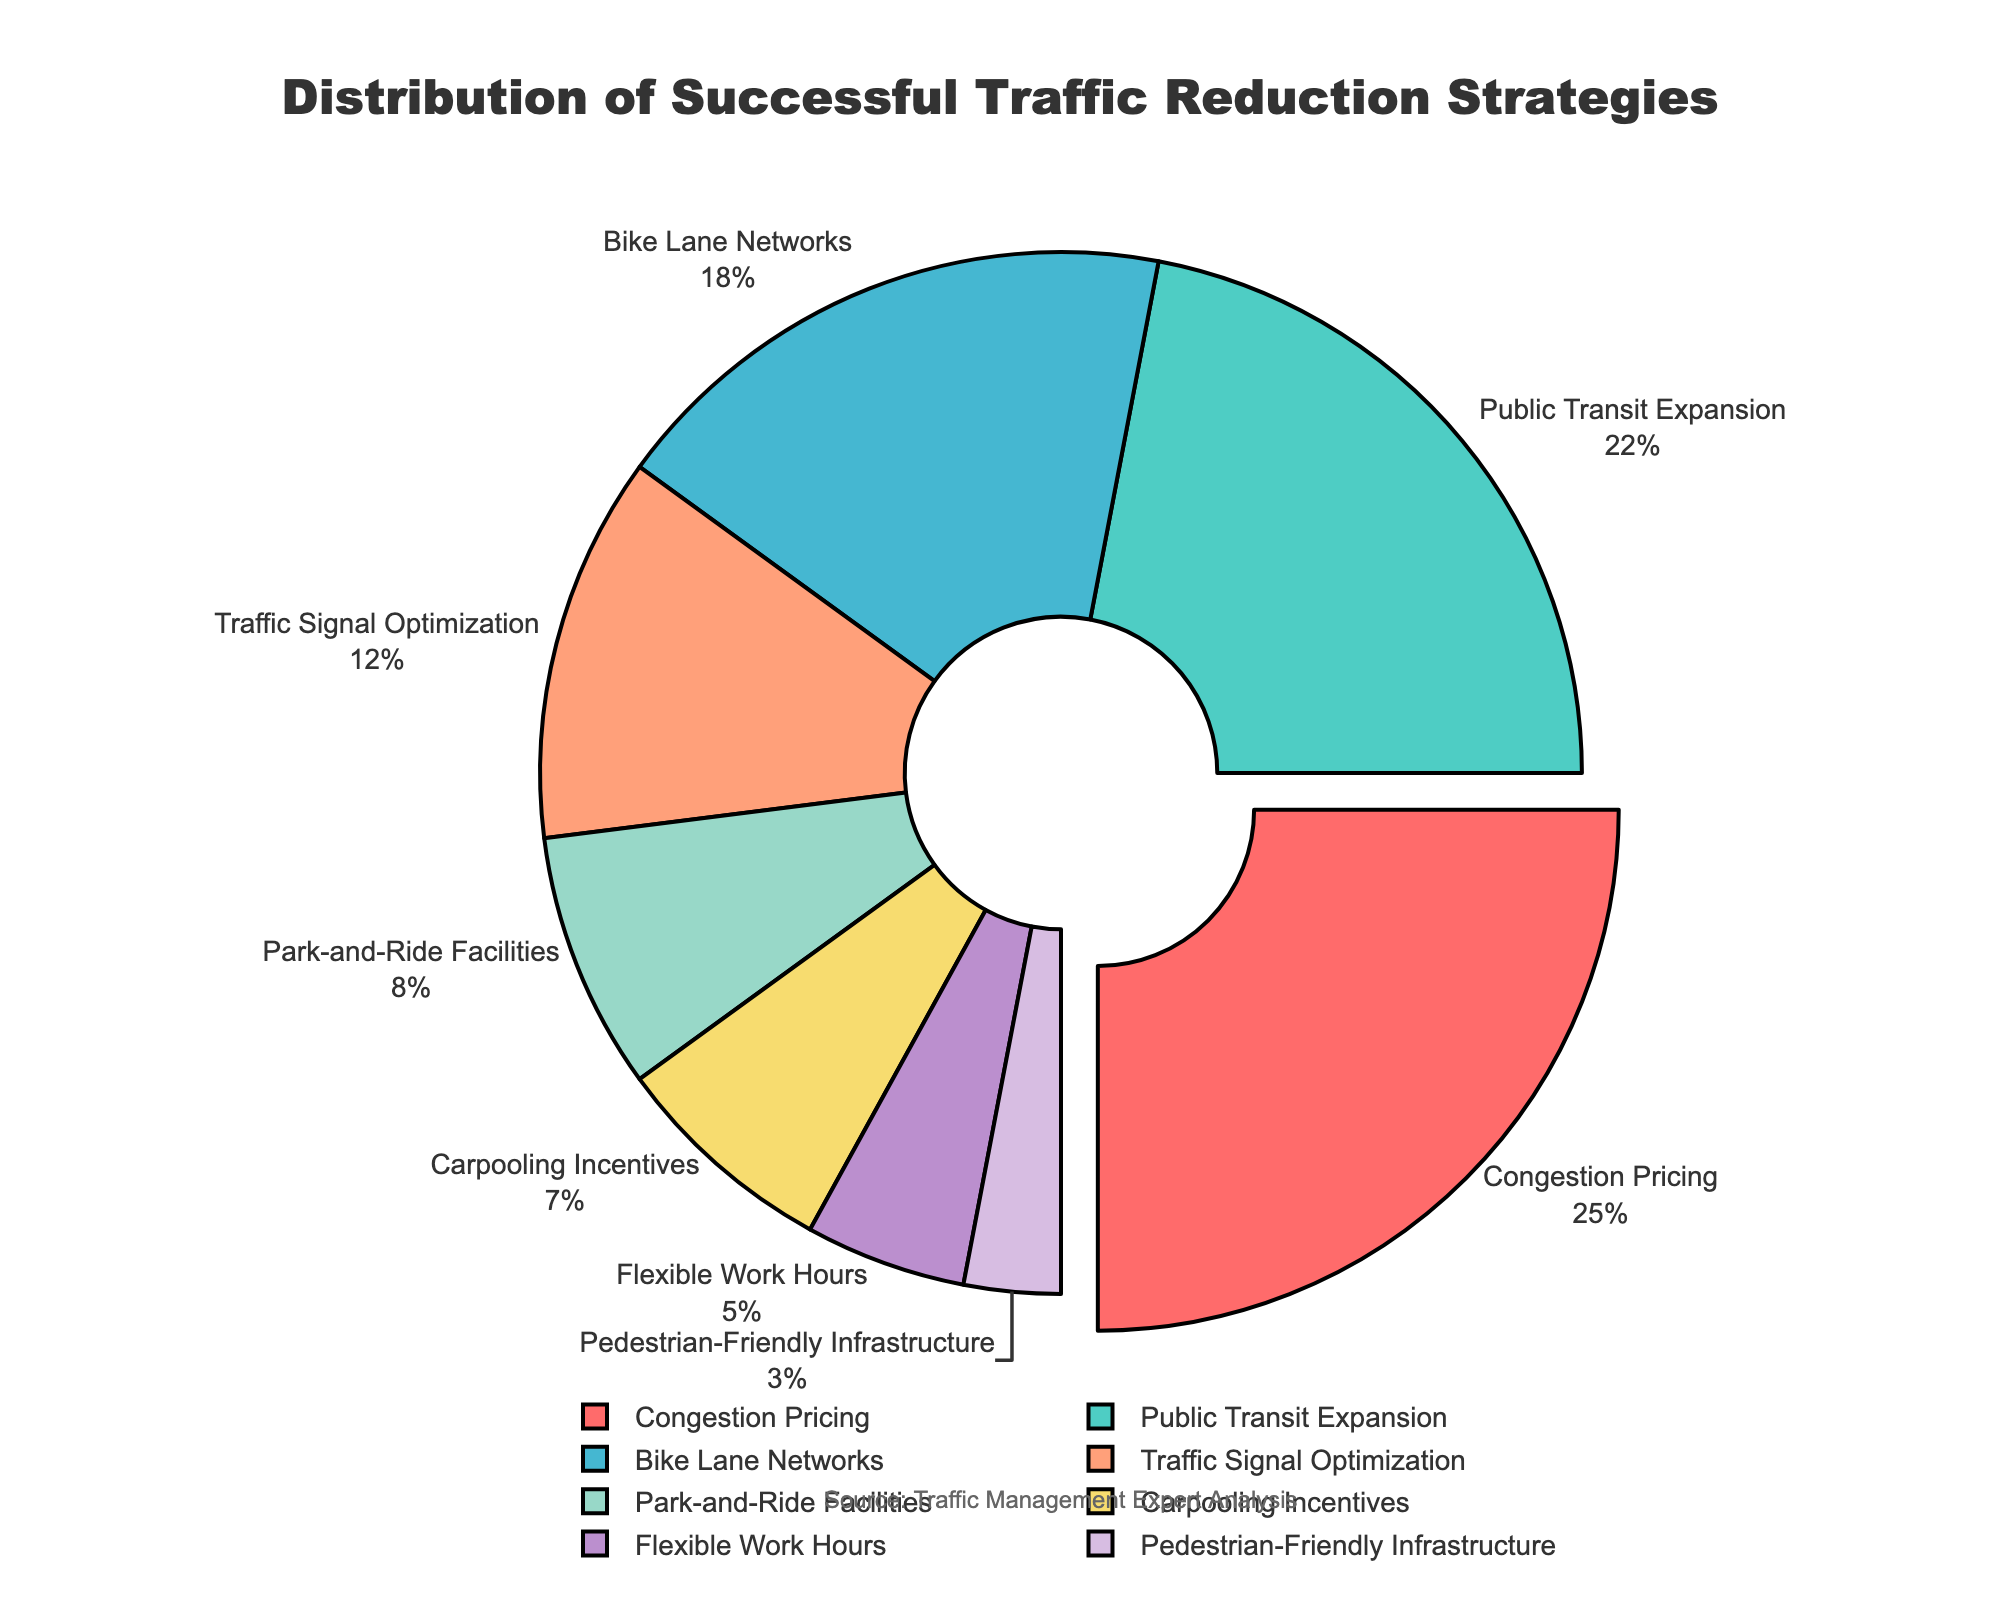What's the largest traffic reduction strategy category? The labels and percentages outside the pie chart reveal that "Congestion Pricing" has the highest percentage at 25%.
Answer: Congestion Pricing Which traffic reduction strategy has a slightly lower percentage than Public Transit Expansion? Public Transit Expansion is 22%, the strategy with a slightly lower percentage is Bike Lane Networks at 18%.
Answer: Bike Lane Networks What's the sum of the percentages for strategies related to shared rides (Carpooling Incentives and Park-and-Ride Facilities)? Carpooling Incentives is 7% and Park-and-Ride Facilities is 8%. Summing them up: 7% + 8% = 15%.
Answer: 15% Which strategy is represented in green? The pie chart segment for "Public Transit Expansion" is colored green, as per given custom palette information.
Answer: Public Transit Expansion How much larger is the percentage of Traffic Signal Optimization compared to Pedestrian-Friendly Infrastructure? Traffic Signal Optimization is 12% and Pedestrian-Friendly Infrastructure is 3%. The difference is 12% - 3% = 9%.
Answer: 9% Which two strategies combined make up more than half of the total strategies? Congestion Pricing (25%) and Public Transit Expansion (22%) together make up 25% + 22% = 47%, which isn't more than half. Adding Bike Lane Networks (18%), we get 47% + 18% = 65% which is but just two isn't sufficient. Focus on the highest: 25% (Congestion Pricing) and 22% (Public Transit).
Answer: None What percentage of strategies involve infrastructure changes (Bike Lane Networks and Pedestrian-Friendly Infrastructure)? Bike Lane Networks is 18% and Pedestrian-Friendly Infrastructure is 3%. Their total is 18% + 3% = 21%.
Answer: 21% Which category pulls out from the pie chart? The pie chart segment labeled "Congestion Pricing" is pulled out, identified by the label and its noticeable separation from the rest.
Answer: Congestion Pricing Order the strategies that fall under 10% from highest to lowest percentage. The strategies under 10% are Park-and-Ride Facilities (8%), Carpooling Incentives (7%), Flexible Work Hours (5%), and Pedestrian-Friendly Infrastructure (3%). Ordering them from highest to lowest: 8%, 7%, 5%, 3%.
Answer: Park-and-Ride Facilities, Carpooling Incentives, Flexible Work Hours, Pedestrian-Friendly Infrastructure What strategy's percentage is exactly twice that of Flexible Work Hours? Flexible Work Hours is 5%, doubled is 5% * 2 = 10%. The nearest strategy close to twice but precise match isn't present hence check individual values if any represents better. No exact twice exists but we have keep close numbers.
Answer: None 